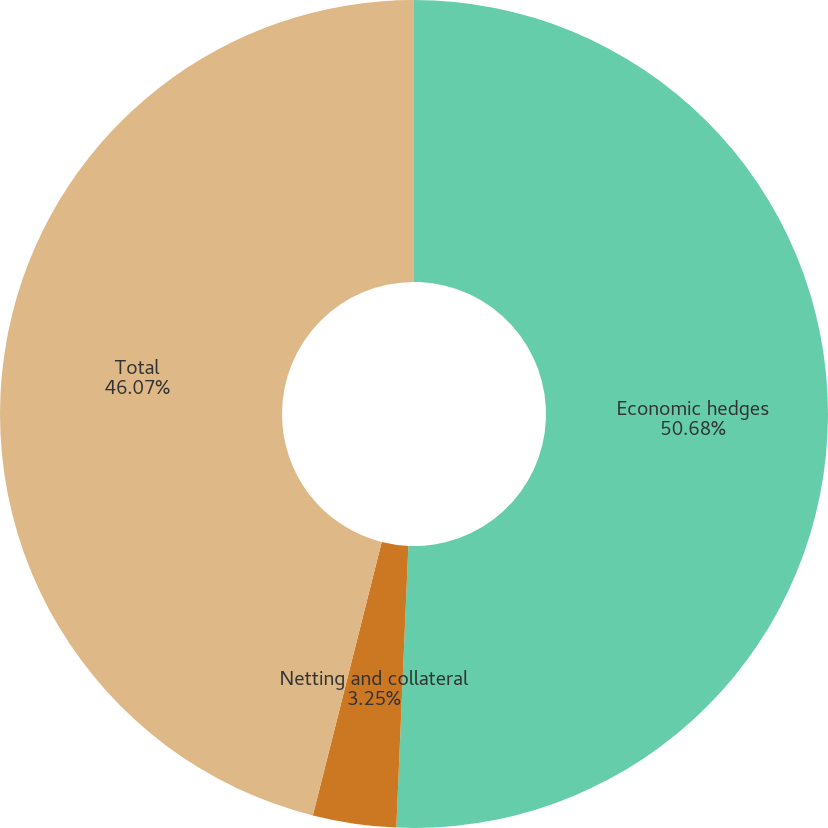Convert chart. <chart><loc_0><loc_0><loc_500><loc_500><pie_chart><fcel>Economic hedges<fcel>Netting and collateral<fcel>Total<nl><fcel>50.68%<fcel>3.25%<fcel>46.07%<nl></chart> 